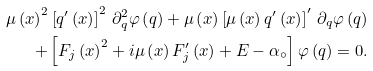<formula> <loc_0><loc_0><loc_500><loc_500>\mu \left ( x \right ) ^ { 2 } \left [ q ^ { \prime } \left ( x \right ) \right ] ^ { 2 } \, \partial _ { q } ^ { 2 } \varphi \left ( q \right ) + \mu \left ( x \right ) \left [ \mu \left ( x \right ) q ^ { \prime } \left ( x \right ) \right ] ^ { \prime } \, \partial _ { q } \varphi \left ( q \right ) \\ + \left [ F _ { j } \left ( x \right ) ^ { 2 } + i \mu \left ( x \right ) F _ { j } ^ { \prime } \left ( x \right ) + E - \alpha _ { \circ } \right ] \varphi \left ( q \right ) = 0 .</formula> 